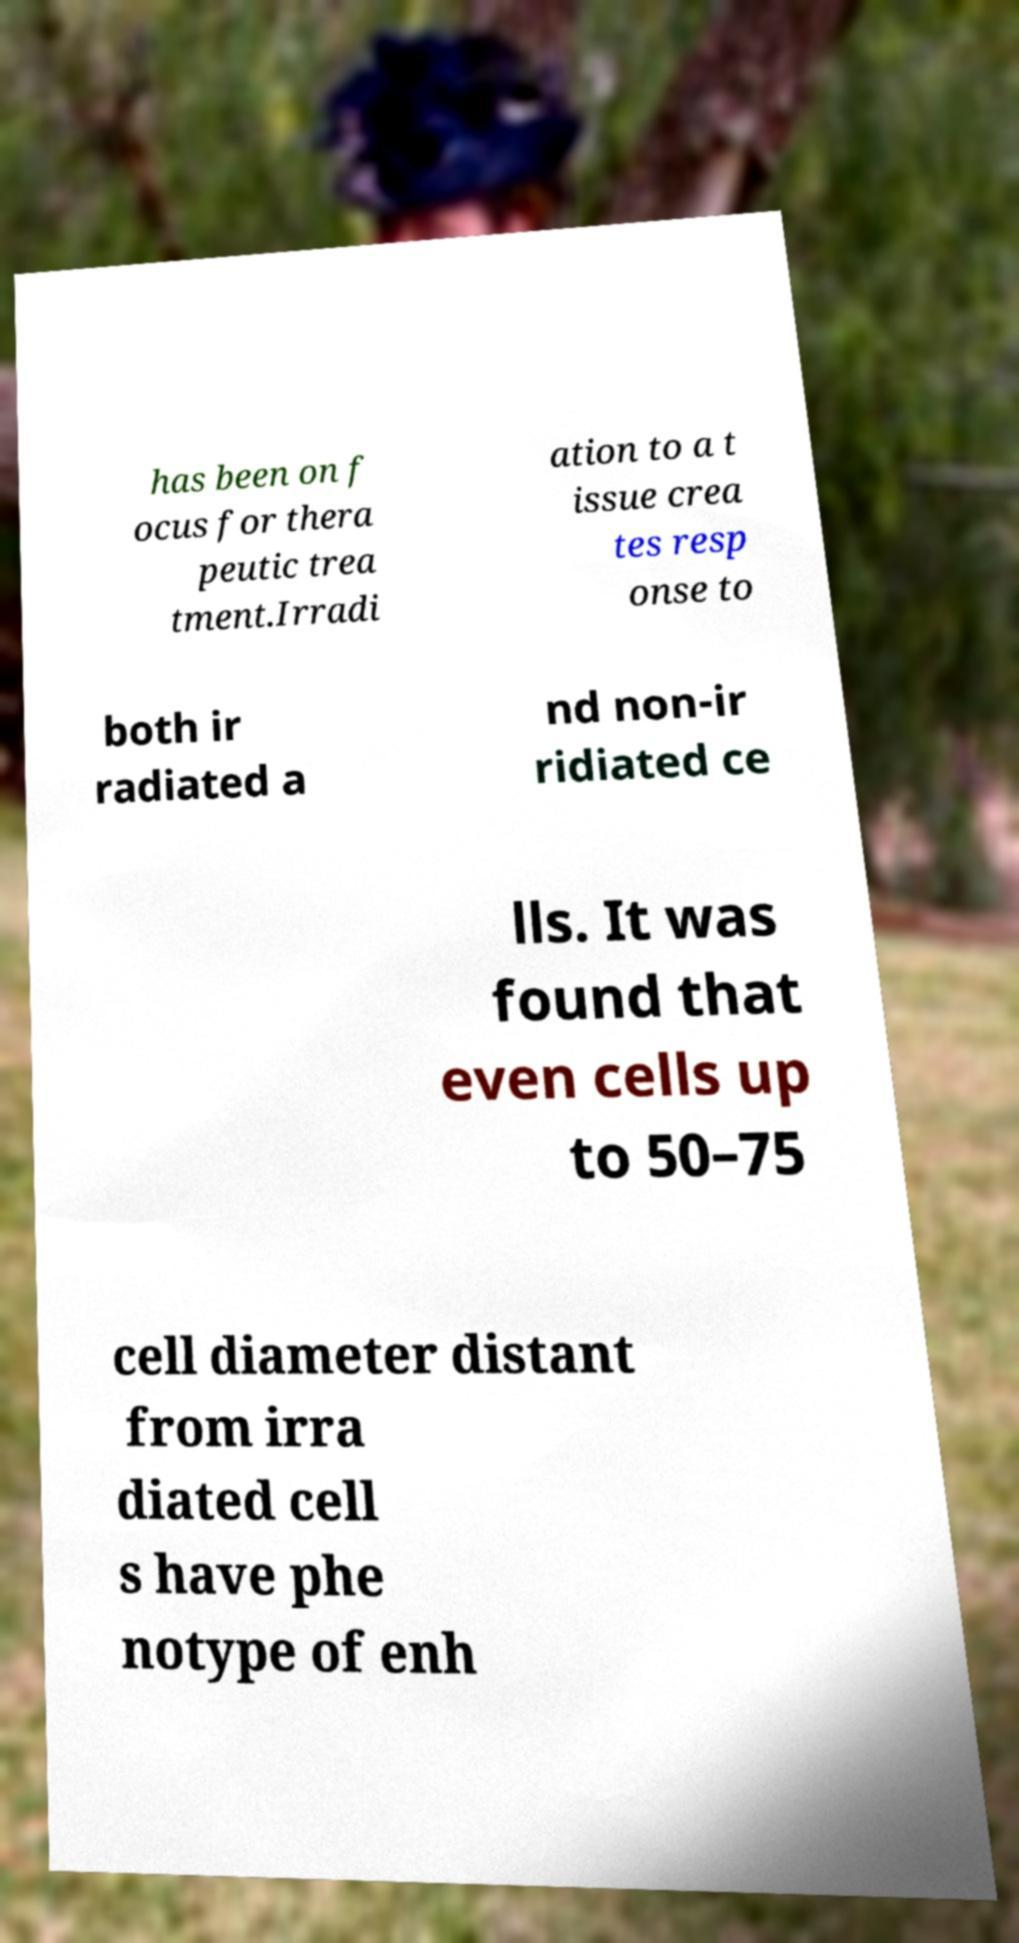Can you accurately transcribe the text from the provided image for me? has been on f ocus for thera peutic trea tment.Irradi ation to a t issue crea tes resp onse to both ir radiated a nd non-ir ridiated ce lls. It was found that even cells up to 50–75 cell diameter distant from irra diated cell s have phe notype of enh 